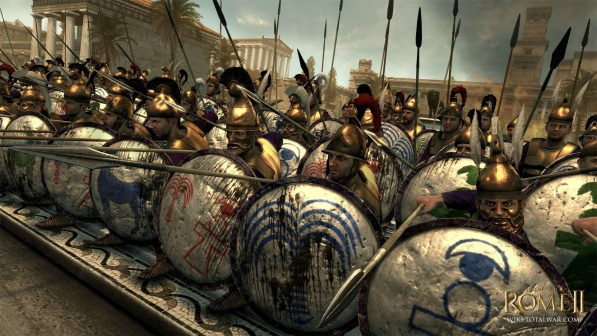Can you explain the significance of the shield designs in Roman military history? Certainly. The designs on Roman shields, often intricate and symbolically charged, served multiple purposes. They were not only used for identification and unit distinction but also held psychological significance, both for the morale of the Roman soldiers and intimidation of the enemy. The specific patterns could indicate the legion to which the soldiers belonged, while the choice of colors and symbols like eagles, lightning bolts, and wolves were meant to invoke the protection of the gods and convey the might of the Roman Empire. 